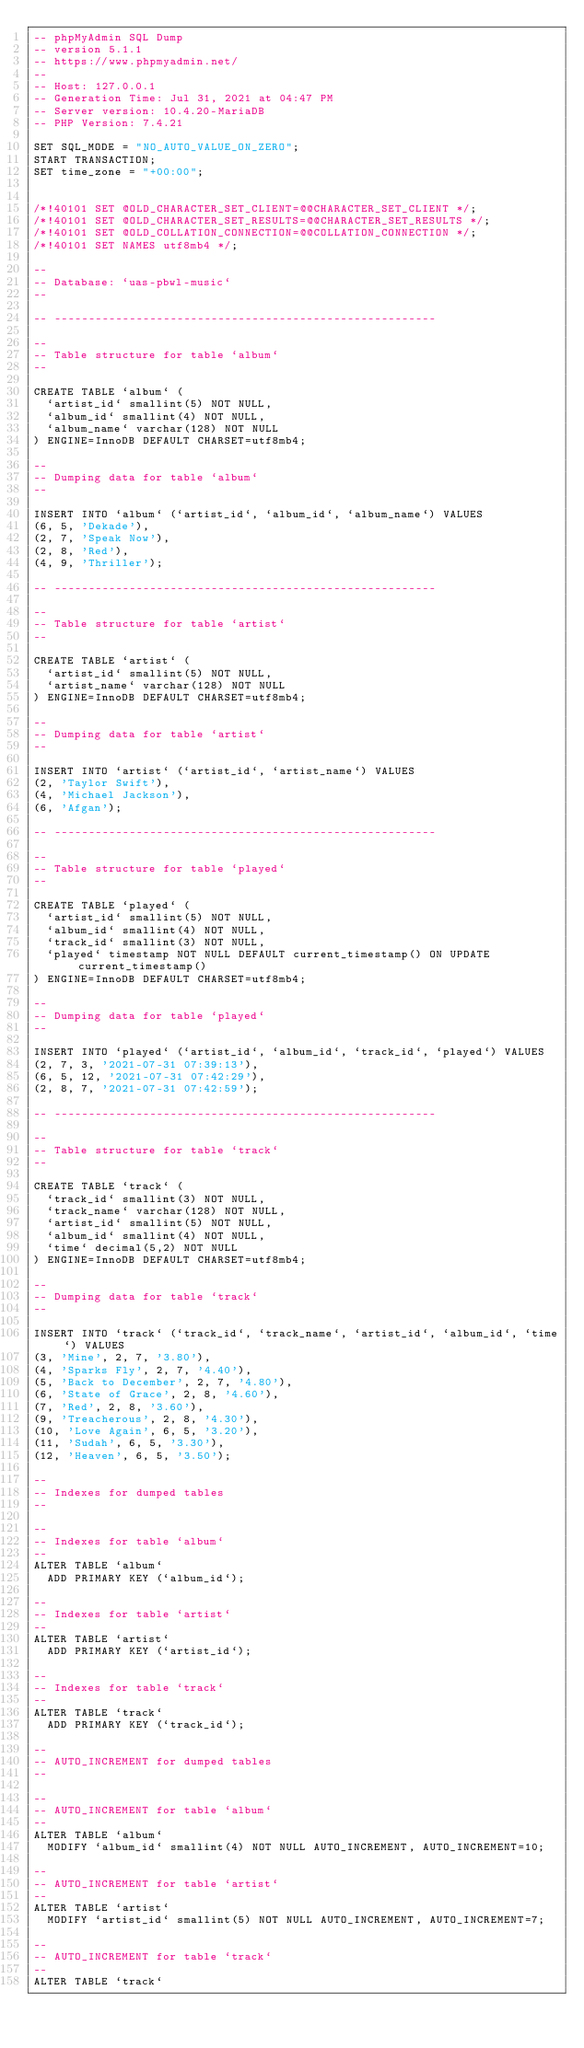<code> <loc_0><loc_0><loc_500><loc_500><_SQL_>-- phpMyAdmin SQL Dump
-- version 5.1.1
-- https://www.phpmyadmin.net/
--
-- Host: 127.0.0.1
-- Generation Time: Jul 31, 2021 at 04:47 PM
-- Server version: 10.4.20-MariaDB
-- PHP Version: 7.4.21

SET SQL_MODE = "NO_AUTO_VALUE_ON_ZERO";
START TRANSACTION;
SET time_zone = "+00:00";


/*!40101 SET @OLD_CHARACTER_SET_CLIENT=@@CHARACTER_SET_CLIENT */;
/*!40101 SET @OLD_CHARACTER_SET_RESULTS=@@CHARACTER_SET_RESULTS */;
/*!40101 SET @OLD_COLLATION_CONNECTION=@@COLLATION_CONNECTION */;
/*!40101 SET NAMES utf8mb4 */;

--
-- Database: `uas-pbwl-music`
--

-- --------------------------------------------------------

--
-- Table structure for table `album`
--

CREATE TABLE `album` (
  `artist_id` smallint(5) NOT NULL,
  `album_id` smallint(4) NOT NULL,
  `album_name` varchar(128) NOT NULL
) ENGINE=InnoDB DEFAULT CHARSET=utf8mb4;

--
-- Dumping data for table `album`
--

INSERT INTO `album` (`artist_id`, `album_id`, `album_name`) VALUES
(6, 5, 'Dekade'),
(2, 7, 'Speak Now'),
(2, 8, 'Red'),
(4, 9, 'Thriller');

-- --------------------------------------------------------

--
-- Table structure for table `artist`
--

CREATE TABLE `artist` (
  `artist_id` smallint(5) NOT NULL,
  `artist_name` varchar(128) NOT NULL
) ENGINE=InnoDB DEFAULT CHARSET=utf8mb4;

--
-- Dumping data for table `artist`
--

INSERT INTO `artist` (`artist_id`, `artist_name`) VALUES
(2, 'Taylor Swift'),
(4, 'Michael Jackson'),
(6, 'Afgan');

-- --------------------------------------------------------

--
-- Table structure for table `played`
--

CREATE TABLE `played` (
  `artist_id` smallint(5) NOT NULL,
  `album_id` smallint(4) NOT NULL,
  `track_id` smallint(3) NOT NULL,
  `played` timestamp NOT NULL DEFAULT current_timestamp() ON UPDATE current_timestamp()
) ENGINE=InnoDB DEFAULT CHARSET=utf8mb4;

--
-- Dumping data for table `played`
--

INSERT INTO `played` (`artist_id`, `album_id`, `track_id`, `played`) VALUES
(2, 7, 3, '2021-07-31 07:39:13'),
(6, 5, 12, '2021-07-31 07:42:29'),
(2, 8, 7, '2021-07-31 07:42:59');

-- --------------------------------------------------------

--
-- Table structure for table `track`
--

CREATE TABLE `track` (
  `track_id` smallint(3) NOT NULL,
  `track_name` varchar(128) NOT NULL,
  `artist_id` smallint(5) NOT NULL,
  `album_id` smallint(4) NOT NULL,
  `time` decimal(5,2) NOT NULL
) ENGINE=InnoDB DEFAULT CHARSET=utf8mb4;

--
-- Dumping data for table `track`
--

INSERT INTO `track` (`track_id`, `track_name`, `artist_id`, `album_id`, `time`) VALUES
(3, 'Mine', 2, 7, '3.80'),
(4, 'Sparks Fly', 2, 7, '4.40'),
(5, 'Back to December', 2, 7, '4.80'),
(6, 'State of Grace', 2, 8, '4.60'),
(7, 'Red', 2, 8, '3.60'),
(9, 'Treacherous', 2, 8, '4.30'),
(10, 'Love Again', 6, 5, '3.20'),
(11, 'Sudah', 6, 5, '3.30'),
(12, 'Heaven', 6, 5, '3.50');

--
-- Indexes for dumped tables
--

--
-- Indexes for table `album`
--
ALTER TABLE `album`
  ADD PRIMARY KEY (`album_id`);

--
-- Indexes for table `artist`
--
ALTER TABLE `artist`
  ADD PRIMARY KEY (`artist_id`);

--
-- Indexes for table `track`
--
ALTER TABLE `track`
  ADD PRIMARY KEY (`track_id`);

--
-- AUTO_INCREMENT for dumped tables
--

--
-- AUTO_INCREMENT for table `album`
--
ALTER TABLE `album`
  MODIFY `album_id` smallint(4) NOT NULL AUTO_INCREMENT, AUTO_INCREMENT=10;

--
-- AUTO_INCREMENT for table `artist`
--
ALTER TABLE `artist`
  MODIFY `artist_id` smallint(5) NOT NULL AUTO_INCREMENT, AUTO_INCREMENT=7;

--
-- AUTO_INCREMENT for table `track`
--
ALTER TABLE `track`</code> 